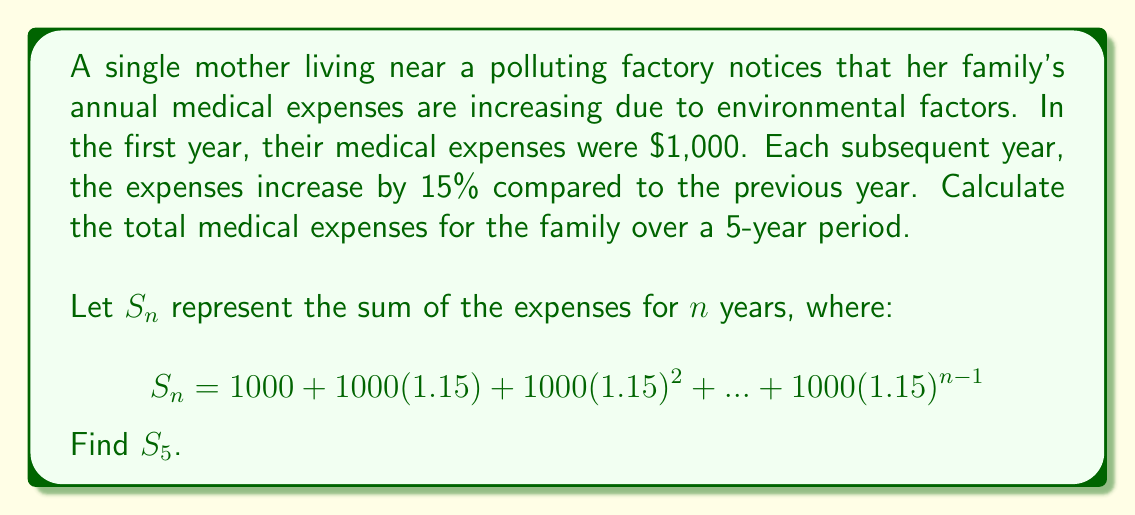Could you help me with this problem? To solve this problem, we need to use the formula for the sum of a geometric series:

$$S_n = \frac{a(1-r^n)}{1-r}$$

Where:
$a$ is the first term (1000 in this case)
$r$ is the common ratio (1.15 in this case)
$n$ is the number of terms (5 in this case)

Let's substitute these values into the formula:

$$S_5 = \frac{1000(1-1.15^5)}{1-1.15}$$

Now, let's calculate step by step:

1) First, calculate $1.15^5$:
   $1.15^5 = 2.0113689$

2) Now, calculate the numerator:
   $1000(1-2.0113689) = 1000(-1.0113689) = -1011.3689$

3) Calculate the denominator:
   $1-1.15 = -0.15$

4) Divide the numerator by the denominator:
   $\frac{-1011.3689}{-0.15} = 6742.4593$

5) Round to the nearest cent:
   $6742.46$

Therefore, the total medical expenses over the 5-year period are $6,742.46.
Answer: $6,742.46 